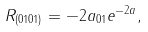<formula> <loc_0><loc_0><loc_500><loc_500>R _ { ( 0 1 0 1 ) } = - 2 a _ { 0 1 } e ^ { - 2 a } ,</formula> 